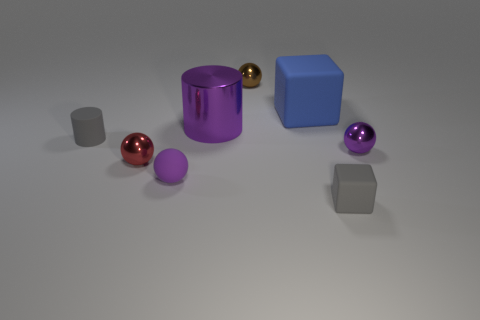Add 2 small brown balls. How many objects exist? 10 Subtract all red balls. Subtract all cyan blocks. How many balls are left? 3 Subtract all cylinders. How many objects are left? 6 Add 1 small blue metal cylinders. How many small blue metal cylinders exist? 1 Subtract 0 cyan balls. How many objects are left? 8 Subtract all small brown balls. Subtract all small purple metal spheres. How many objects are left? 6 Add 7 large purple metal cylinders. How many large purple metal cylinders are left? 8 